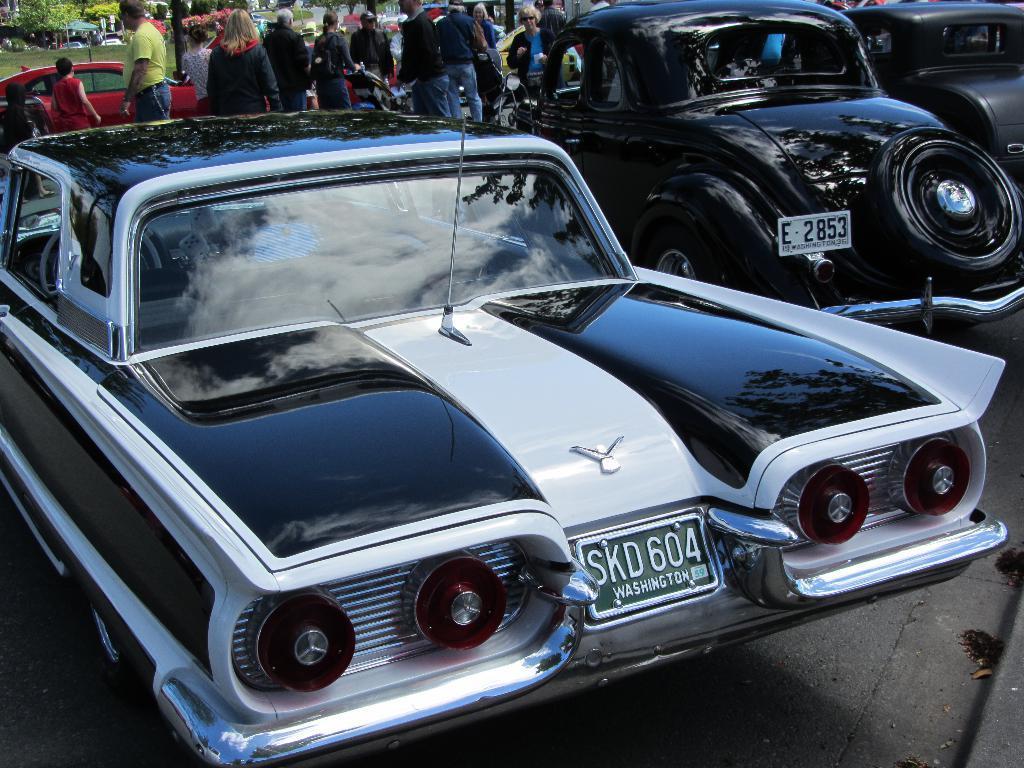Could you give a brief overview of what you see in this image? In this picture I can see vehicles on the road, there are group of people standing, there is grass and trees. 